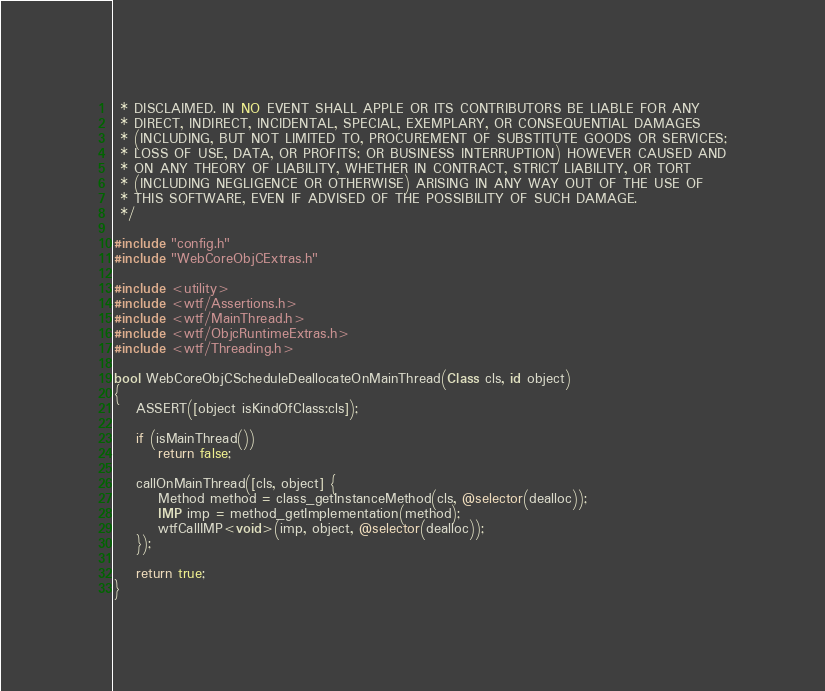Convert code to text. <code><loc_0><loc_0><loc_500><loc_500><_ObjectiveC_> * DISCLAIMED. IN NO EVENT SHALL APPLE OR ITS CONTRIBUTORS BE LIABLE FOR ANY
 * DIRECT, INDIRECT, INCIDENTAL, SPECIAL, EXEMPLARY, OR CONSEQUENTIAL DAMAGES
 * (INCLUDING, BUT NOT LIMITED TO, PROCUREMENT OF SUBSTITUTE GOODS OR SERVICES;
 * LOSS OF USE, DATA, OR PROFITS; OR BUSINESS INTERRUPTION) HOWEVER CAUSED AND
 * ON ANY THEORY OF LIABILITY, WHETHER IN CONTRACT, STRICT LIABILITY, OR TORT
 * (INCLUDING NEGLIGENCE OR OTHERWISE) ARISING IN ANY WAY OUT OF THE USE OF
 * THIS SOFTWARE, EVEN IF ADVISED OF THE POSSIBILITY OF SUCH DAMAGE.
 */

#include "config.h"
#include "WebCoreObjCExtras.h"

#include <utility>
#include <wtf/Assertions.h>
#include <wtf/MainThread.h>
#include <wtf/ObjcRuntimeExtras.h>
#include <wtf/Threading.h>

bool WebCoreObjCScheduleDeallocateOnMainThread(Class cls, id object)
{
    ASSERT([object isKindOfClass:cls]);

    if (isMainThread())
        return false;

    callOnMainThread([cls, object] {
        Method method = class_getInstanceMethod(cls, @selector(dealloc));
        IMP imp = method_getImplementation(method);
        wtfCallIMP<void>(imp, object, @selector(dealloc));
    });

    return true;
}

</code> 